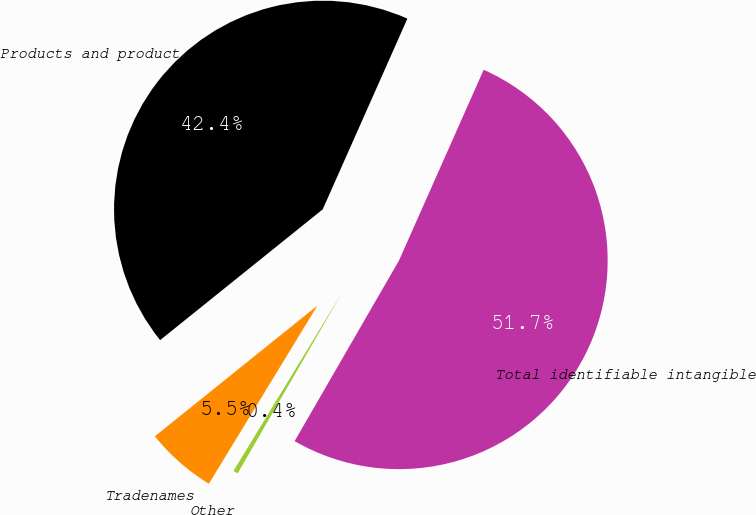Convert chart to OTSL. <chart><loc_0><loc_0><loc_500><loc_500><pie_chart><fcel>Products and product rights<fcel>Tradenames<fcel>Other<fcel>Total identifiable intangible<nl><fcel>42.43%<fcel>5.51%<fcel>0.37%<fcel>51.69%<nl></chart> 